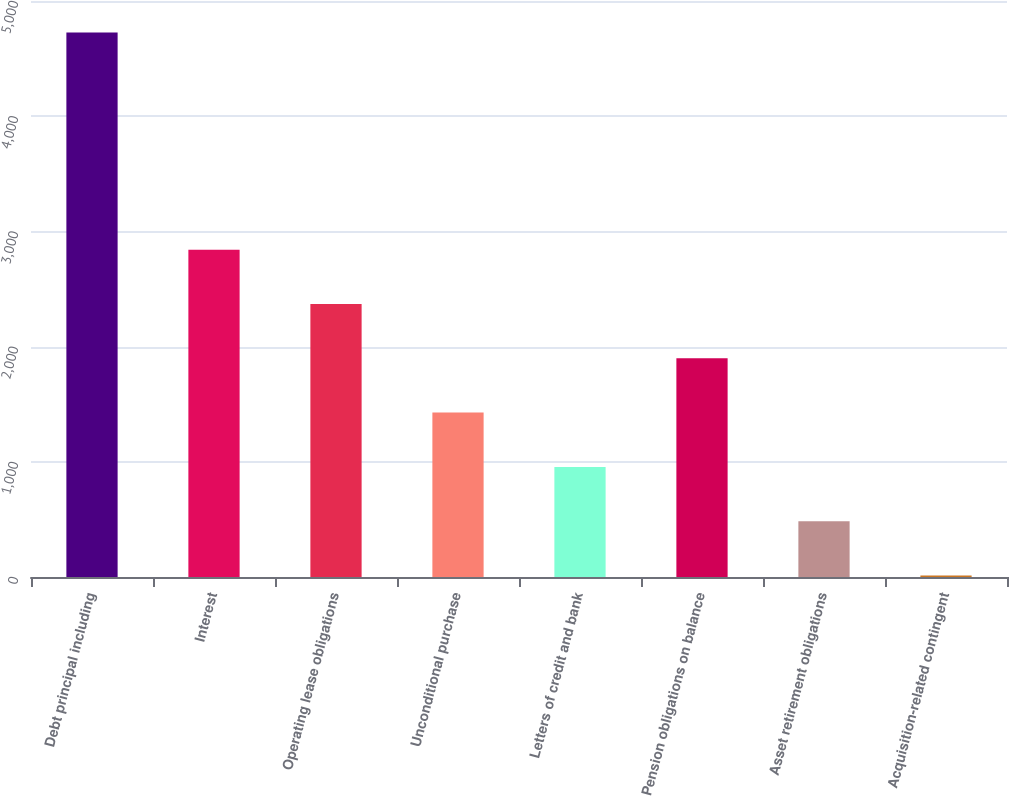Convert chart. <chart><loc_0><loc_0><loc_500><loc_500><bar_chart><fcel>Debt principal including<fcel>Interest<fcel>Operating lease obligations<fcel>Unconditional purchase<fcel>Letters of credit and bank<fcel>Pension obligations on balance<fcel>Asset retirement obligations<fcel>Acquisition-related contingent<nl><fcel>4727<fcel>2841.4<fcel>2370<fcel>1427.2<fcel>955.8<fcel>1898.6<fcel>484.4<fcel>13<nl></chart> 